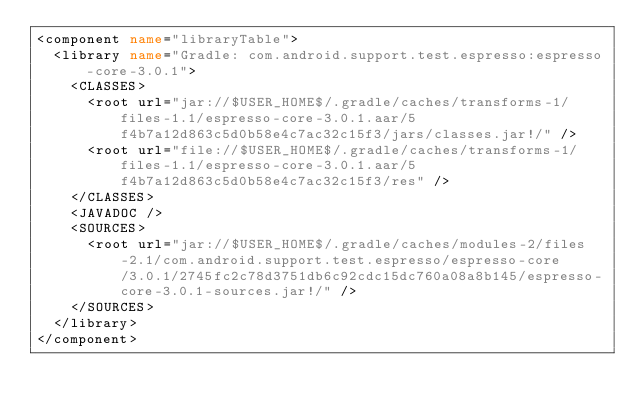<code> <loc_0><loc_0><loc_500><loc_500><_XML_><component name="libraryTable">
  <library name="Gradle: com.android.support.test.espresso:espresso-core-3.0.1">
    <CLASSES>
      <root url="jar://$USER_HOME$/.gradle/caches/transforms-1/files-1.1/espresso-core-3.0.1.aar/5f4b7a12d863c5d0b58e4c7ac32c15f3/jars/classes.jar!/" />
      <root url="file://$USER_HOME$/.gradle/caches/transforms-1/files-1.1/espresso-core-3.0.1.aar/5f4b7a12d863c5d0b58e4c7ac32c15f3/res" />
    </CLASSES>
    <JAVADOC />
    <SOURCES>
      <root url="jar://$USER_HOME$/.gradle/caches/modules-2/files-2.1/com.android.support.test.espresso/espresso-core/3.0.1/2745fc2c78d3751db6c92cdc15dc760a08a8b145/espresso-core-3.0.1-sources.jar!/" />
    </SOURCES>
  </library>
</component></code> 